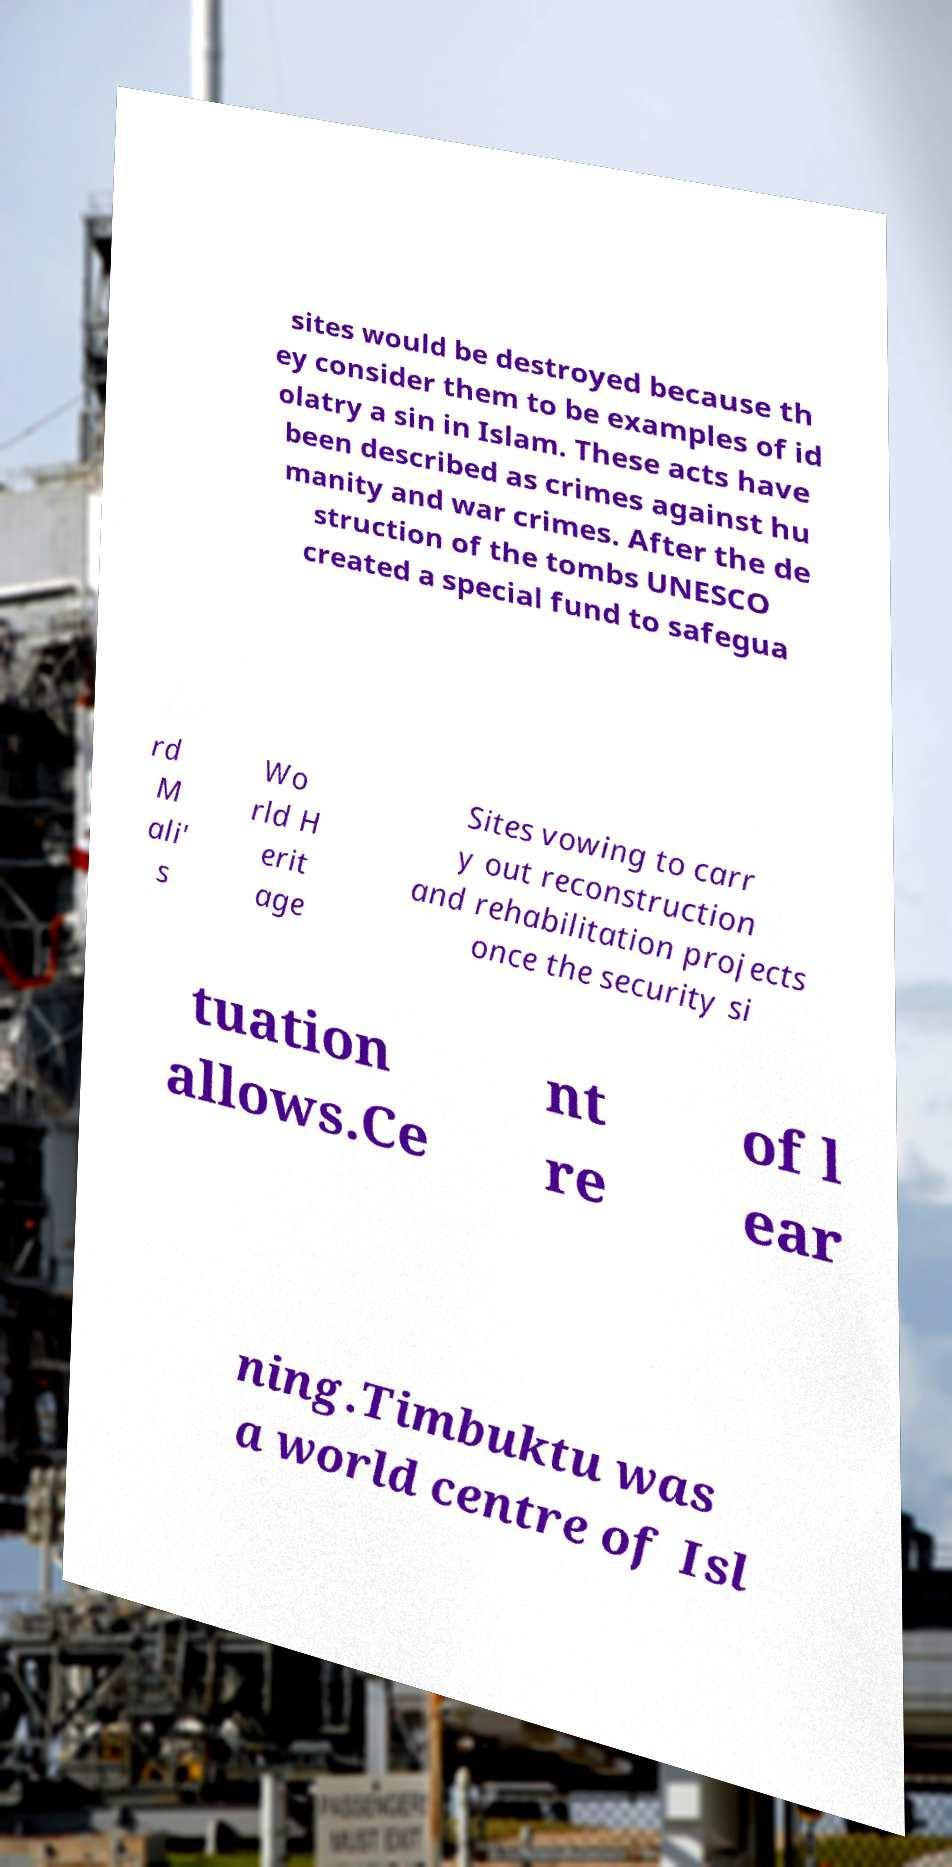For documentation purposes, I need the text within this image transcribed. Could you provide that? sites would be destroyed because th ey consider them to be examples of id olatry a sin in Islam. These acts have been described as crimes against hu manity and war crimes. After the de struction of the tombs UNESCO created a special fund to safegua rd M ali' s Wo rld H erit age Sites vowing to carr y out reconstruction and rehabilitation projects once the security si tuation allows.Ce nt re of l ear ning.Timbuktu was a world centre of Isl 